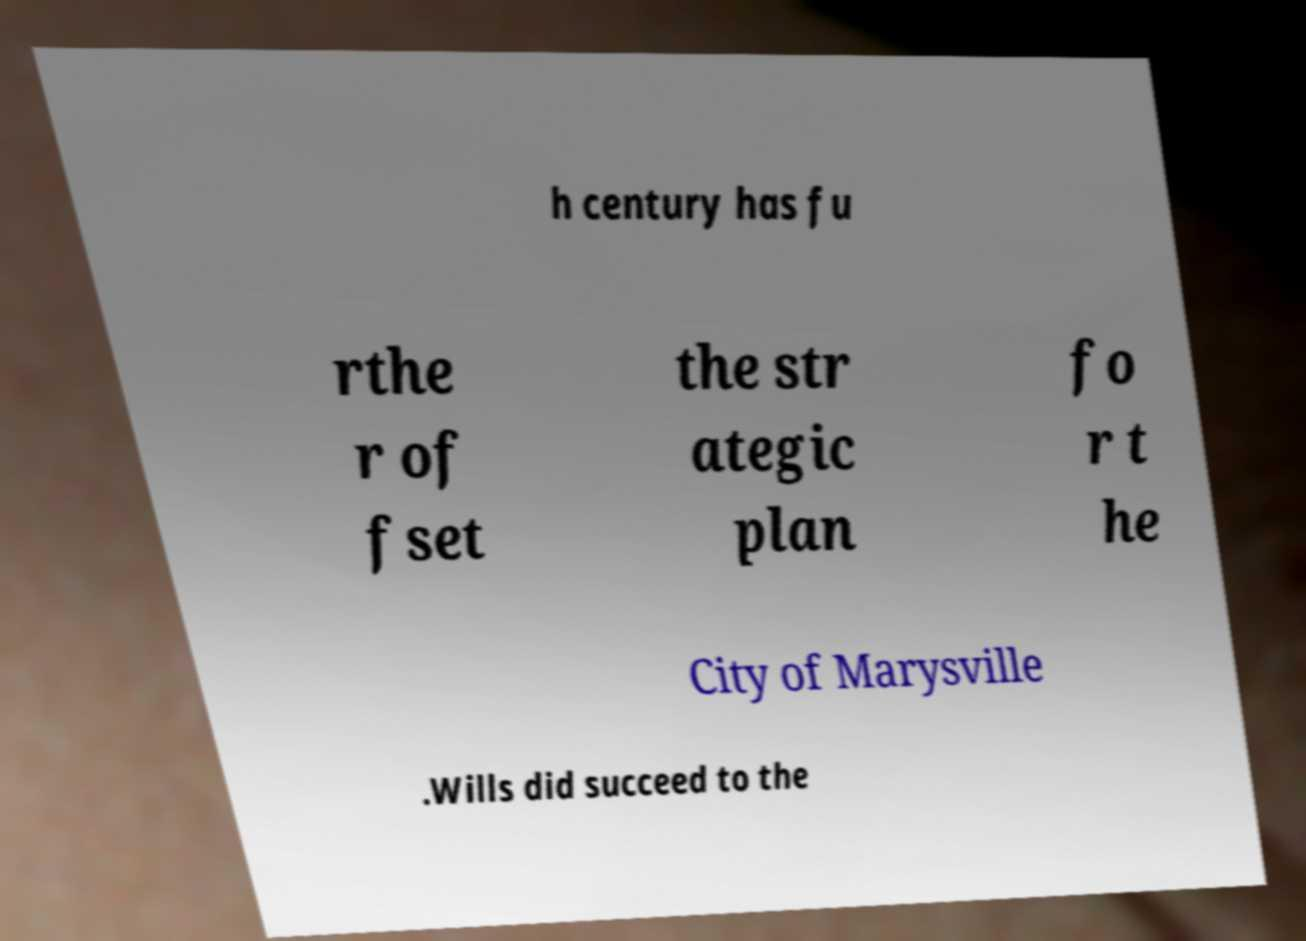I need the written content from this picture converted into text. Can you do that? h century has fu rthe r of fset the str ategic plan fo r t he City of Marysville .Wills did succeed to the 